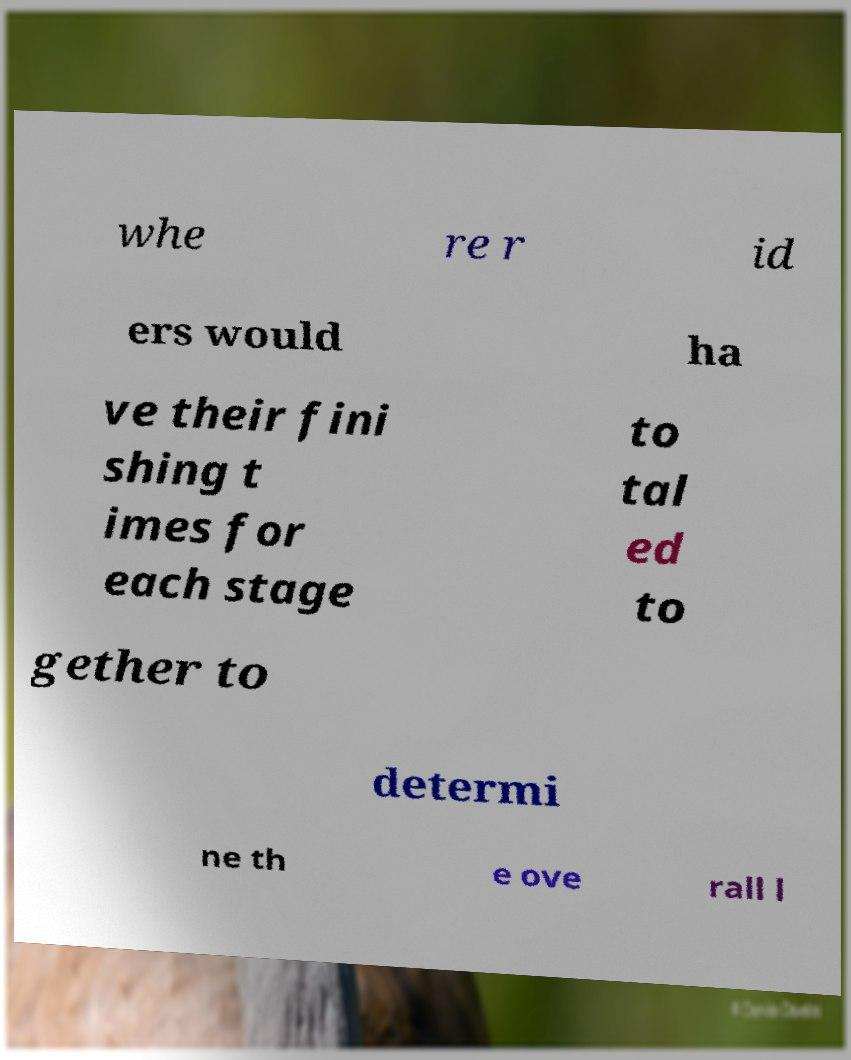Please read and relay the text visible in this image. What does it say? whe re r id ers would ha ve their fini shing t imes for each stage to tal ed to gether to determi ne th e ove rall l 